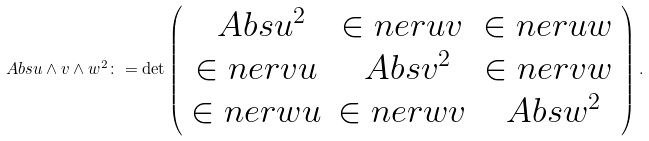<formula> <loc_0><loc_0><loc_500><loc_500>\ A b s { u \wedge v \wedge w } ^ { 2 } \colon = \det \left ( \begin{array} { c c c } \ A b s { u } ^ { 2 } & \in n e r { u } { v } & \in n e r { u } { w } \\ \in n e r { v } { u } & \ A b s { v } ^ { 2 } & \in n e r { v } { w } \\ \in n e r { w } { u } & \in n e r { w } { v } & \ A b s { w } ^ { 2 } \end{array} \right ) .</formula> 